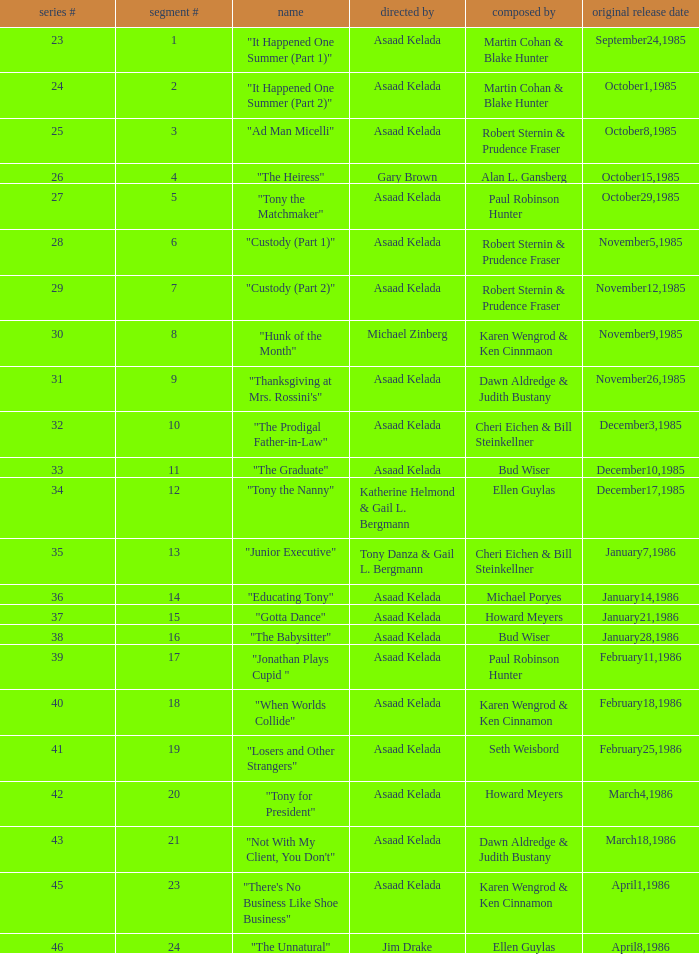Who were the authors of series episode #25? Robert Sternin & Prudence Fraser. 